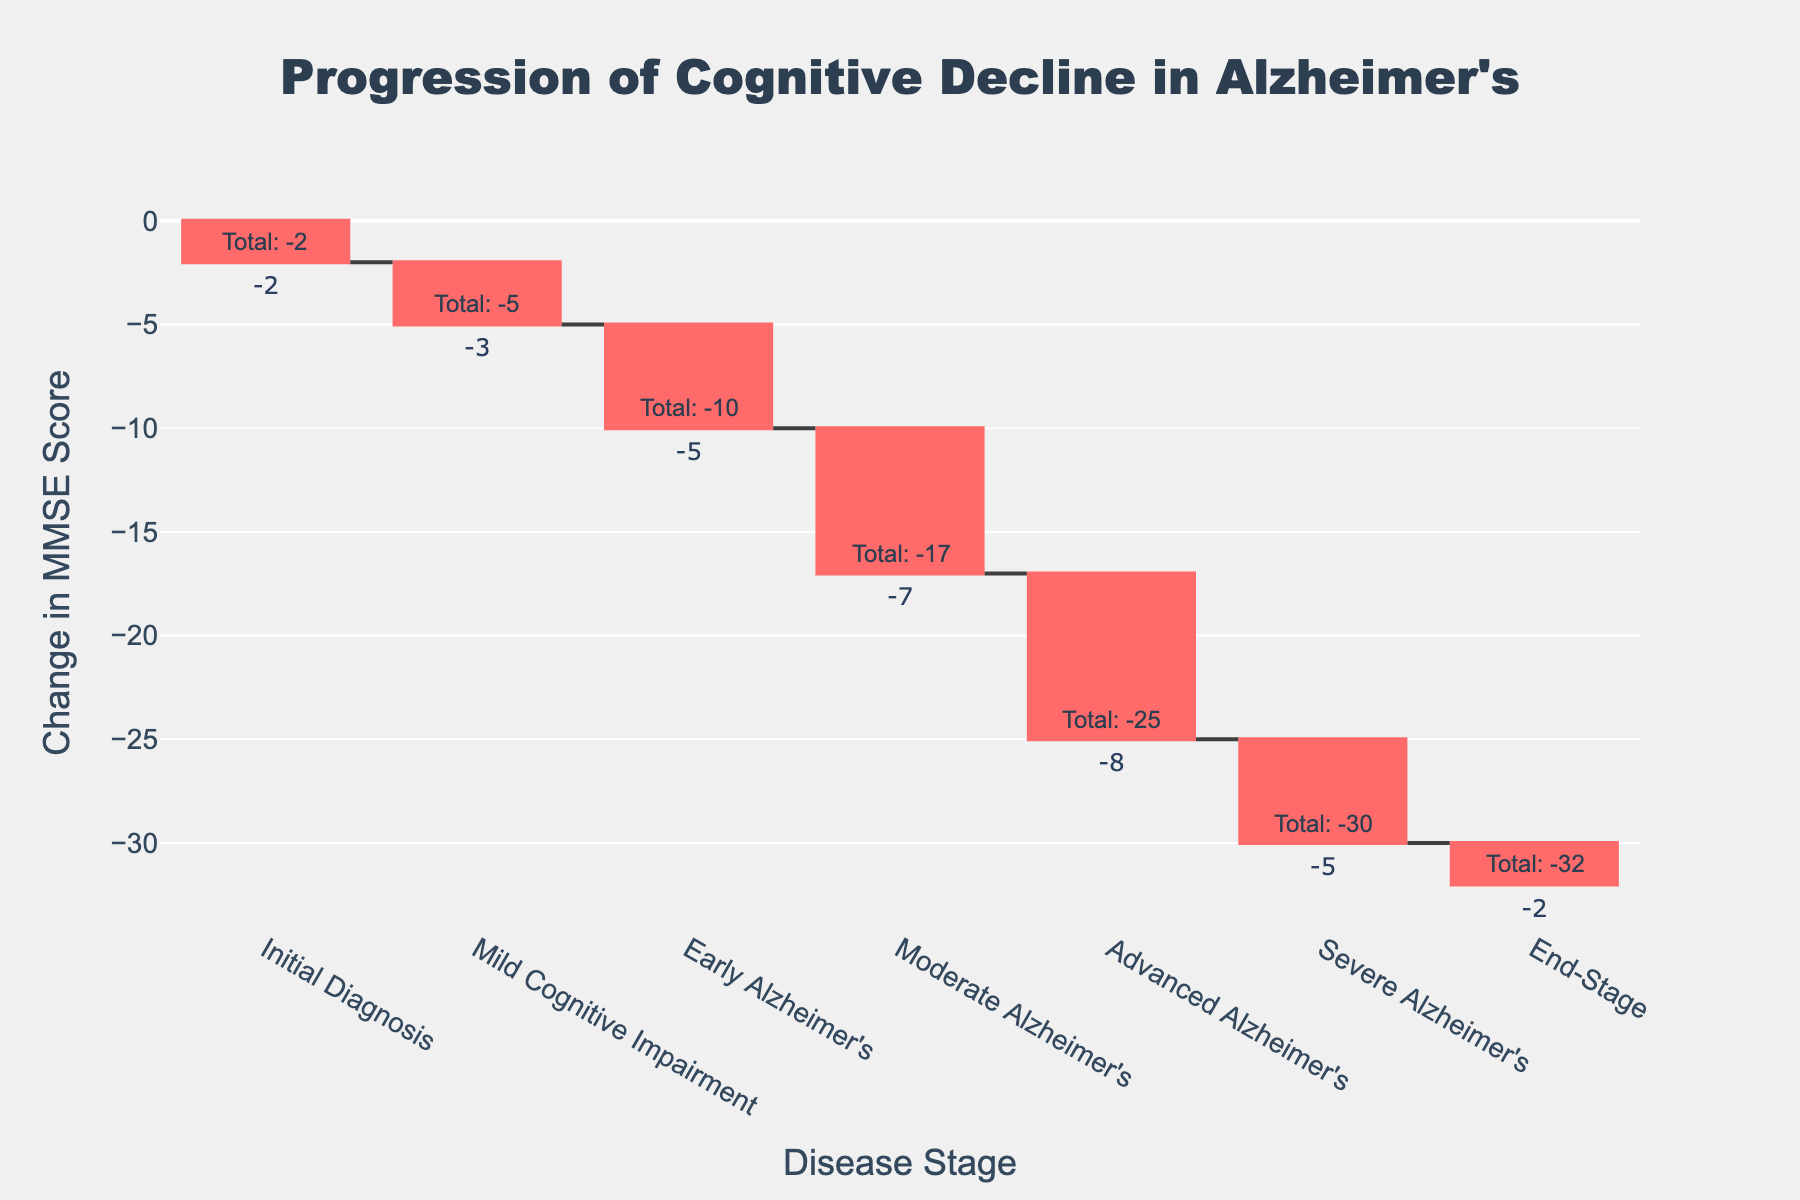What is the title of the waterfall chart? The title is generally found at the top of the chart and is used to describe the main topic or data that the chart represents. In this case, look at the top center of the figure where the title is displayed.
Answer: "Progression of Cognitive Decline in Alzheimer's" What is the change in MMSE score at the 'Moderate Alzheimer's' stage? Locate the bar labeled 'Moderate Alzheimer's' on the x-axis and read the value associated with it.
Answer: -7 Which disease stage shows the greatest decline in MMSE score? Compare the heights of the bars representing the decline in MMSE scores across all stages. The tallest bar represents the greatest decline.
Answer: Advanced Alzheimer's What is the cumulative MMSE score change by the end of the 'Early Alzheimer's' stage? Sum the changes in MMSE scores up to and including the 'Early Alzheimer's' stage and look for the cumulative value annotated near the corresponding bar.
Answer: -10 How does the MMSE score change from the 'Mild Cognitive Impairment' stage to the 'Early Alzheimer's' stage? Identify the changes in MMSE scores for both stages and calculate the difference between them: -5 (Early Alzheimer's) - (-3 (Mild Cognitive Impairment)) = -2.
Answer: -2 What stage follows the smallest decline in MMSE score? Examine each bar's height and look for the stage with the smallest negative value. The 'Initial Diagnosis' and 'End-Stage' have the smallest declines, both showing a change of -2.
Answer: Initial Diagnosis or End-Stage What is the total cumulative MMSE score change by the 'End-Stage'? Locate the cumulative value annotated near the 'End-Stage' bar, which represents the sum of the changes in MMSE scores from the initial stage to the 'End-Stage'.
Answer: -32 Which stage shows a greater decline in MMSE score, 'Mild Cognitive Impairment' or 'Severe Alzheimer's'? Compare the heights of the bars for 'Mild Cognitive Impairment' and 'Severe Alzheimer's'. The taller bar represents a greater decline.
Answer: Severe Alzheimer's How much does the MMSE score decline from the 'Advanced Alzheimer's' stage to the 'Severe Alzheimer's' stage? Identify the changes in MMSE scores for both stages and calculate the difference between them: -5 (Severe Alzheimer's) - (-8 (Advanced Alzheimer's)) = +3.
Answer: +3 What is the cumulative change in MMSE score by the 'Moderate Alzheimer's' stage? Add the changes in MMSE scores from the initial diagnosis to the 'Moderate Alzheimer's' stage: -2 + (-3) + (-5) + (-7) = -17.
Answer: -17 